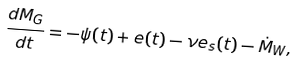Convert formula to latex. <formula><loc_0><loc_0><loc_500><loc_500>\frac { d M _ { G } } { d t } = - \psi ( t ) + e ( t ) - \nu e _ { s } ( t ) - \dot { M } _ { W } ,</formula> 